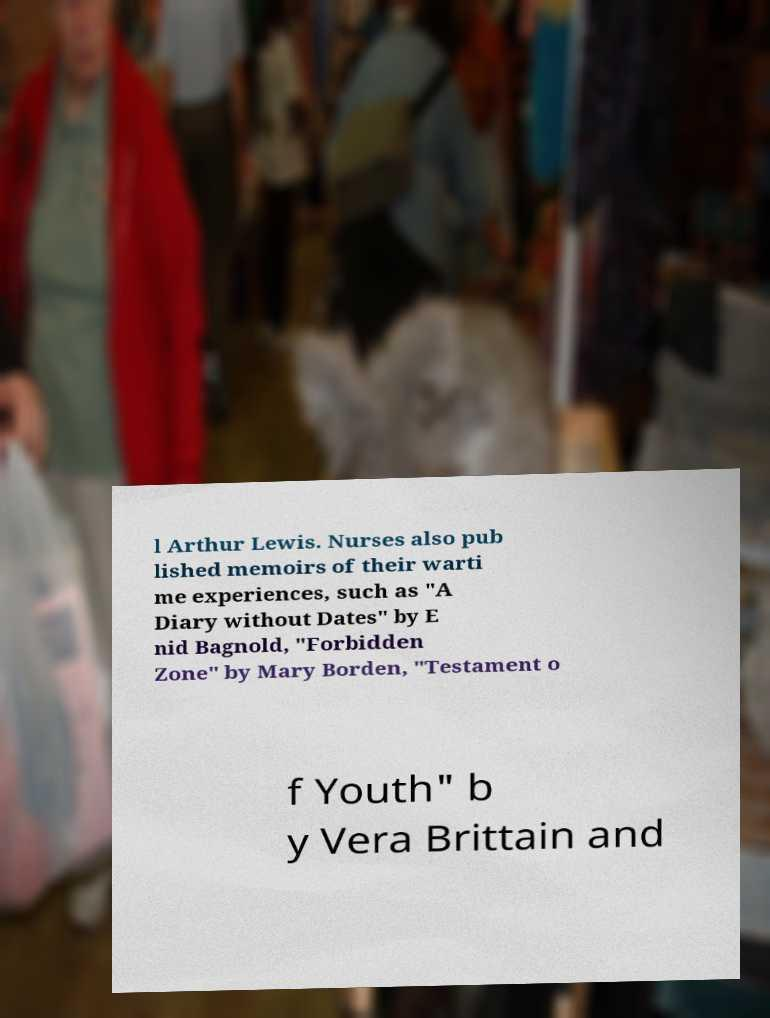Please identify and transcribe the text found in this image. l Arthur Lewis. Nurses also pub lished memoirs of their warti me experiences, such as "A Diary without Dates" by E nid Bagnold, "Forbidden Zone" by Mary Borden, "Testament o f Youth" b y Vera Brittain and 